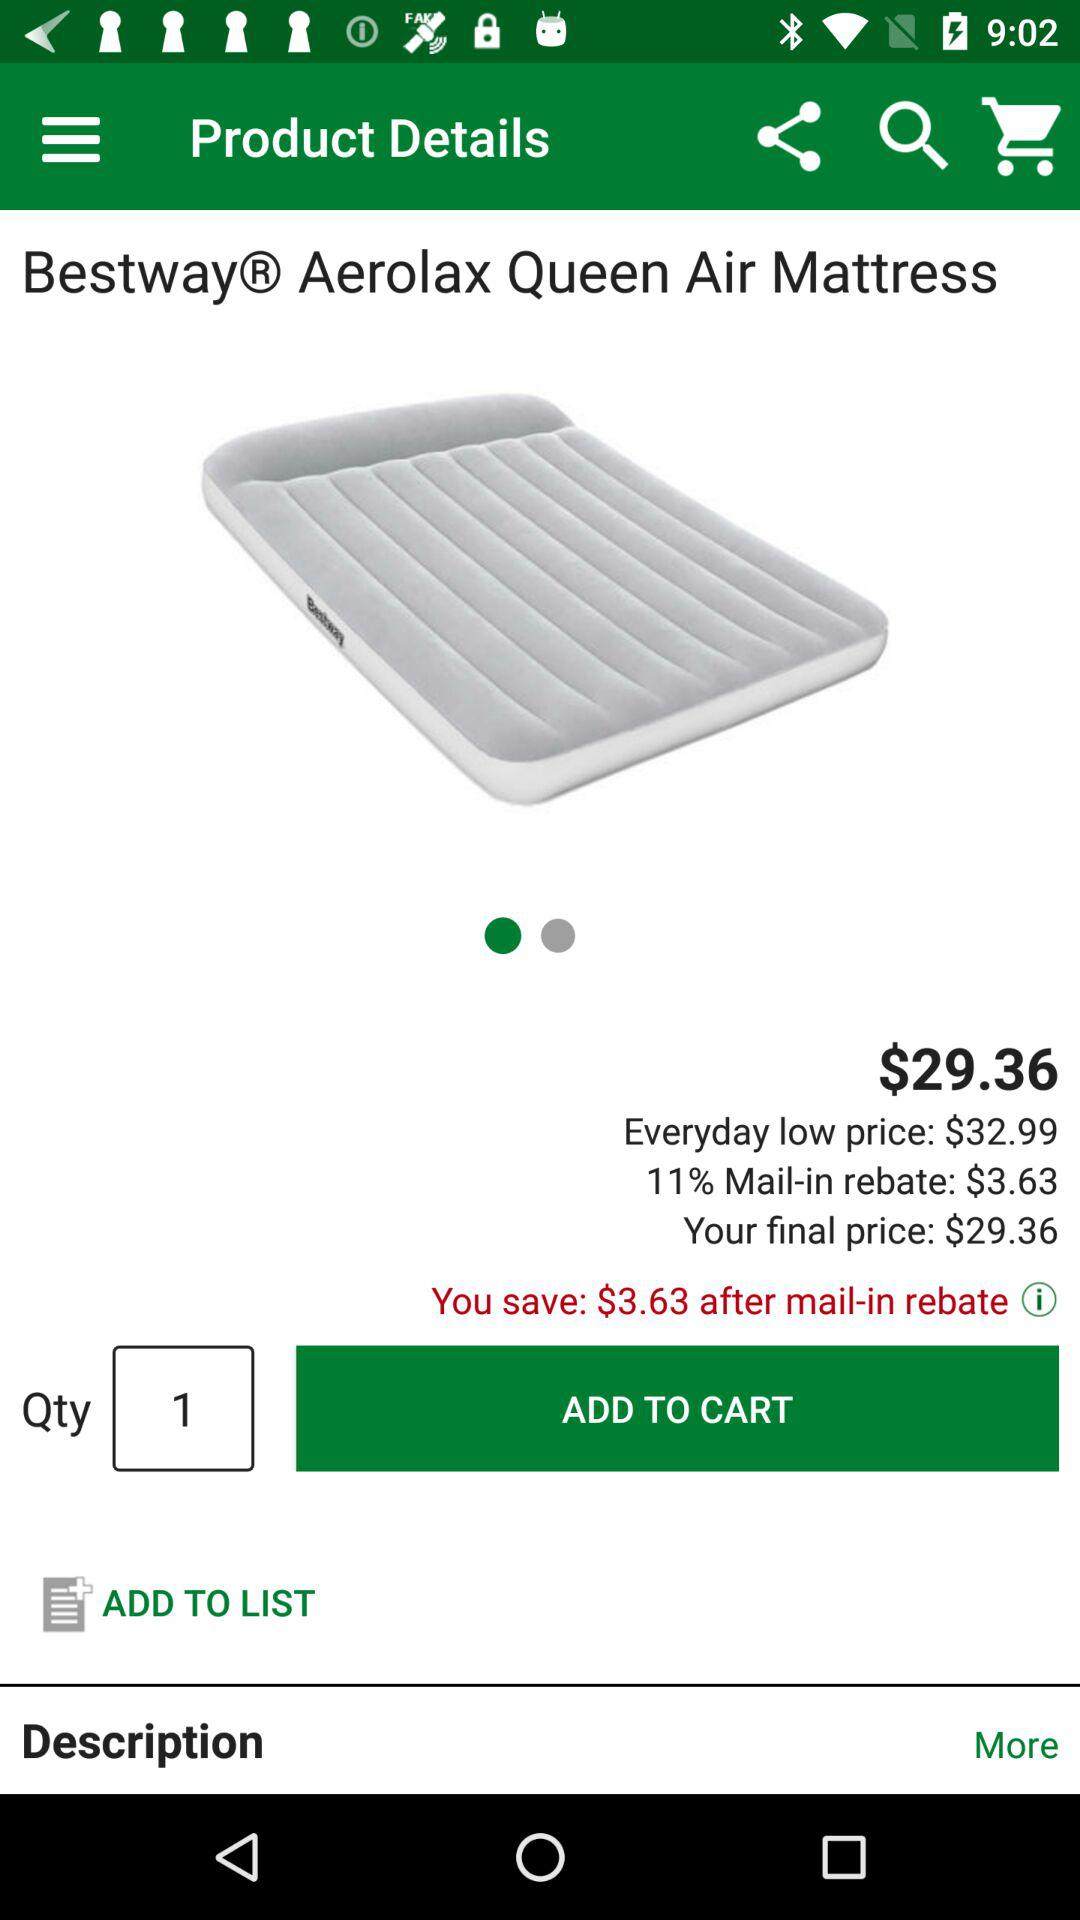How much do I save after the mail-in rebate?
Answer the question using a single word or phrase. $3.63 